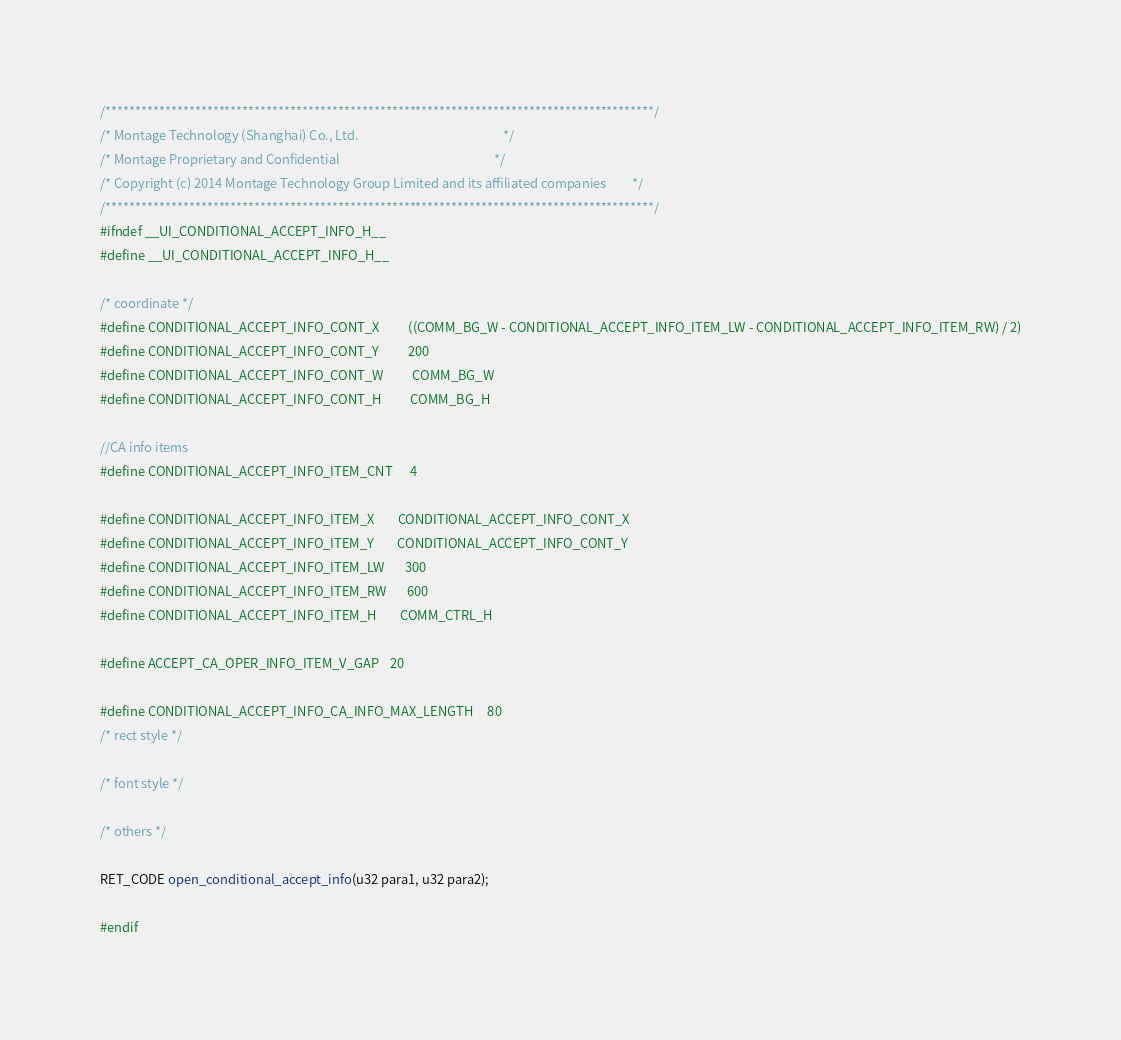Convert code to text. <code><loc_0><loc_0><loc_500><loc_500><_C_>/********************************************************************************************/
/* Montage Technology (Shanghai) Co., Ltd.                                                  */
/* Montage Proprietary and Confidential                                                     */
/* Copyright (c) 2014 Montage Technology Group Limited and its affiliated companies         */
/********************************************************************************************/
#ifndef __UI_CONDITIONAL_ACCEPT_INFO_H__
#define __UI_CONDITIONAL_ACCEPT_INFO_H__

/* coordinate */
#define CONDITIONAL_ACCEPT_INFO_CONT_X          ((COMM_BG_W - CONDITIONAL_ACCEPT_INFO_ITEM_LW - CONDITIONAL_ACCEPT_INFO_ITEM_RW) / 2)
#define CONDITIONAL_ACCEPT_INFO_CONT_Y          200
#define CONDITIONAL_ACCEPT_INFO_CONT_W          COMM_BG_W
#define CONDITIONAL_ACCEPT_INFO_CONT_H          COMM_BG_H

//CA info items
#define CONDITIONAL_ACCEPT_INFO_ITEM_CNT      4

#define CONDITIONAL_ACCEPT_INFO_ITEM_X        CONDITIONAL_ACCEPT_INFO_CONT_X
#define CONDITIONAL_ACCEPT_INFO_ITEM_Y        CONDITIONAL_ACCEPT_INFO_CONT_Y
#define CONDITIONAL_ACCEPT_INFO_ITEM_LW       300
#define CONDITIONAL_ACCEPT_INFO_ITEM_RW       600
#define CONDITIONAL_ACCEPT_INFO_ITEM_H        COMM_CTRL_H

#define ACCEPT_CA_OPER_INFO_ITEM_V_GAP    20

#define CONDITIONAL_ACCEPT_INFO_CA_INFO_MAX_LENGTH     80
/* rect style */

/* font style */

/* others */

RET_CODE open_conditional_accept_info(u32 para1, u32 para2);

#endif


</code> 